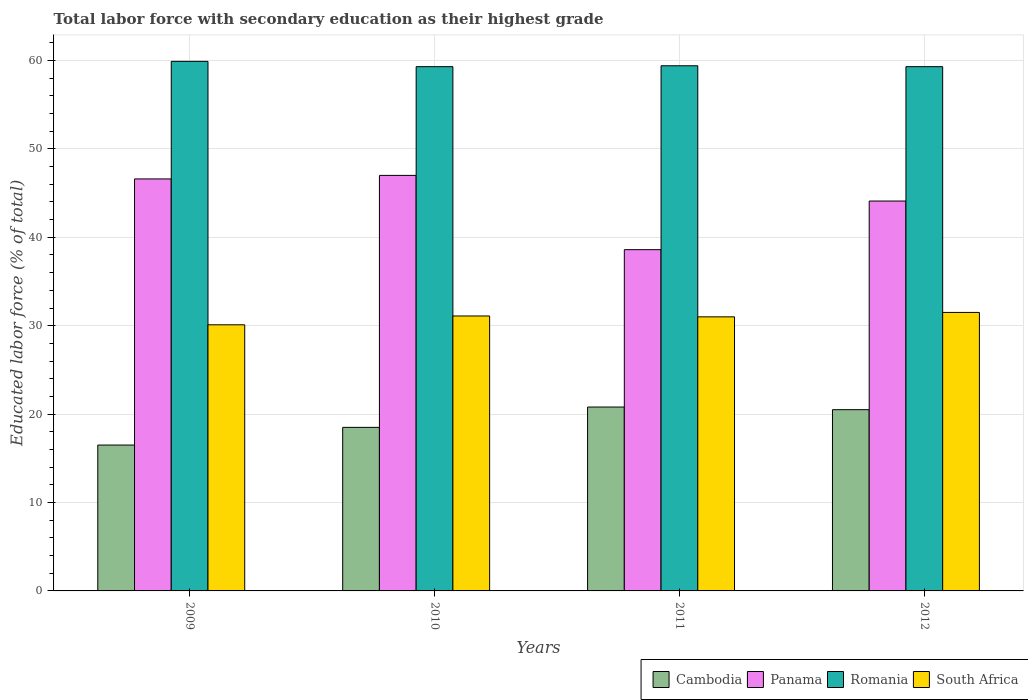Are the number of bars per tick equal to the number of legend labels?
Make the answer very short. Yes. How many bars are there on the 3rd tick from the left?
Provide a succinct answer. 4. How many bars are there on the 3rd tick from the right?
Your answer should be very brief. 4. In how many cases, is the number of bars for a given year not equal to the number of legend labels?
Provide a short and direct response. 0. What is the percentage of total labor force with primary education in Panama in 2009?
Provide a succinct answer. 46.6. Across all years, what is the maximum percentage of total labor force with primary education in Cambodia?
Your answer should be compact. 20.8. In which year was the percentage of total labor force with primary education in Romania maximum?
Make the answer very short. 2009. What is the total percentage of total labor force with primary education in South Africa in the graph?
Provide a short and direct response. 123.7. What is the difference between the percentage of total labor force with primary education in Romania in 2009 and that in 2011?
Provide a succinct answer. 0.5. What is the difference between the percentage of total labor force with primary education in Panama in 2010 and the percentage of total labor force with primary education in Cambodia in 2012?
Make the answer very short. 26.5. What is the average percentage of total labor force with primary education in Romania per year?
Make the answer very short. 59.48. In the year 2010, what is the difference between the percentage of total labor force with primary education in Cambodia and percentage of total labor force with primary education in Panama?
Your answer should be compact. -28.5. What is the ratio of the percentage of total labor force with primary education in Panama in 2011 to that in 2012?
Make the answer very short. 0.88. What is the difference between the highest and the second highest percentage of total labor force with primary education in Romania?
Your answer should be compact. 0.5. What is the difference between the highest and the lowest percentage of total labor force with primary education in Cambodia?
Make the answer very short. 4.3. In how many years, is the percentage of total labor force with primary education in Romania greater than the average percentage of total labor force with primary education in Romania taken over all years?
Your answer should be compact. 1. What does the 4th bar from the left in 2011 represents?
Ensure brevity in your answer.  South Africa. What does the 4th bar from the right in 2010 represents?
Provide a succinct answer. Cambodia. What is the difference between two consecutive major ticks on the Y-axis?
Provide a short and direct response. 10. Does the graph contain any zero values?
Your response must be concise. No. Does the graph contain grids?
Provide a short and direct response. Yes. How many legend labels are there?
Offer a terse response. 4. What is the title of the graph?
Ensure brevity in your answer.  Total labor force with secondary education as their highest grade. What is the label or title of the Y-axis?
Your answer should be compact. Educated labor force (% of total). What is the Educated labor force (% of total) in Cambodia in 2009?
Give a very brief answer. 16.5. What is the Educated labor force (% of total) of Panama in 2009?
Your response must be concise. 46.6. What is the Educated labor force (% of total) in Romania in 2009?
Offer a very short reply. 59.9. What is the Educated labor force (% of total) in South Africa in 2009?
Your answer should be very brief. 30.1. What is the Educated labor force (% of total) of Cambodia in 2010?
Provide a short and direct response. 18.5. What is the Educated labor force (% of total) of Romania in 2010?
Keep it short and to the point. 59.3. What is the Educated labor force (% of total) of South Africa in 2010?
Offer a terse response. 31.1. What is the Educated labor force (% of total) in Cambodia in 2011?
Offer a terse response. 20.8. What is the Educated labor force (% of total) in Panama in 2011?
Your answer should be very brief. 38.6. What is the Educated labor force (% of total) of Romania in 2011?
Ensure brevity in your answer.  59.4. What is the Educated labor force (% of total) of South Africa in 2011?
Give a very brief answer. 31. What is the Educated labor force (% of total) of Panama in 2012?
Offer a terse response. 44.1. What is the Educated labor force (% of total) of Romania in 2012?
Keep it short and to the point. 59.3. What is the Educated labor force (% of total) of South Africa in 2012?
Ensure brevity in your answer.  31.5. Across all years, what is the maximum Educated labor force (% of total) in Cambodia?
Your response must be concise. 20.8. Across all years, what is the maximum Educated labor force (% of total) in Romania?
Your answer should be very brief. 59.9. Across all years, what is the maximum Educated labor force (% of total) of South Africa?
Provide a short and direct response. 31.5. Across all years, what is the minimum Educated labor force (% of total) of Panama?
Provide a short and direct response. 38.6. Across all years, what is the minimum Educated labor force (% of total) of Romania?
Offer a very short reply. 59.3. Across all years, what is the minimum Educated labor force (% of total) of South Africa?
Keep it short and to the point. 30.1. What is the total Educated labor force (% of total) of Cambodia in the graph?
Give a very brief answer. 76.3. What is the total Educated labor force (% of total) in Panama in the graph?
Keep it short and to the point. 176.3. What is the total Educated labor force (% of total) in Romania in the graph?
Your answer should be compact. 237.9. What is the total Educated labor force (% of total) in South Africa in the graph?
Offer a terse response. 123.7. What is the difference between the Educated labor force (% of total) in Panama in 2009 and that in 2010?
Provide a succinct answer. -0.4. What is the difference between the Educated labor force (% of total) of Panama in 2009 and that in 2011?
Offer a terse response. 8. What is the difference between the Educated labor force (% of total) of Romania in 2009 and that in 2011?
Keep it short and to the point. 0.5. What is the difference between the Educated labor force (% of total) of South Africa in 2009 and that in 2011?
Provide a short and direct response. -0.9. What is the difference between the Educated labor force (% of total) of Panama in 2009 and that in 2012?
Your answer should be very brief. 2.5. What is the difference between the Educated labor force (% of total) in South Africa in 2009 and that in 2012?
Your answer should be very brief. -1.4. What is the difference between the Educated labor force (% of total) of Cambodia in 2010 and that in 2011?
Provide a short and direct response. -2.3. What is the difference between the Educated labor force (% of total) of Panama in 2010 and that in 2011?
Ensure brevity in your answer.  8.4. What is the difference between the Educated labor force (% of total) of Romania in 2010 and that in 2011?
Offer a very short reply. -0.1. What is the difference between the Educated labor force (% of total) in South Africa in 2010 and that in 2011?
Give a very brief answer. 0.1. What is the difference between the Educated labor force (% of total) of Cambodia in 2010 and that in 2012?
Provide a succinct answer. -2. What is the difference between the Educated labor force (% of total) in Romania in 2010 and that in 2012?
Offer a very short reply. 0. What is the difference between the Educated labor force (% of total) in Panama in 2011 and that in 2012?
Your answer should be very brief. -5.5. What is the difference between the Educated labor force (% of total) of South Africa in 2011 and that in 2012?
Your answer should be very brief. -0.5. What is the difference between the Educated labor force (% of total) in Cambodia in 2009 and the Educated labor force (% of total) in Panama in 2010?
Make the answer very short. -30.5. What is the difference between the Educated labor force (% of total) in Cambodia in 2009 and the Educated labor force (% of total) in Romania in 2010?
Keep it short and to the point. -42.8. What is the difference between the Educated labor force (% of total) of Cambodia in 2009 and the Educated labor force (% of total) of South Africa in 2010?
Your response must be concise. -14.6. What is the difference between the Educated labor force (% of total) in Panama in 2009 and the Educated labor force (% of total) in Romania in 2010?
Make the answer very short. -12.7. What is the difference between the Educated labor force (% of total) in Panama in 2009 and the Educated labor force (% of total) in South Africa in 2010?
Your answer should be compact. 15.5. What is the difference between the Educated labor force (% of total) of Romania in 2009 and the Educated labor force (% of total) of South Africa in 2010?
Your answer should be very brief. 28.8. What is the difference between the Educated labor force (% of total) in Cambodia in 2009 and the Educated labor force (% of total) in Panama in 2011?
Your response must be concise. -22.1. What is the difference between the Educated labor force (% of total) in Cambodia in 2009 and the Educated labor force (% of total) in Romania in 2011?
Your response must be concise. -42.9. What is the difference between the Educated labor force (% of total) of Cambodia in 2009 and the Educated labor force (% of total) of South Africa in 2011?
Make the answer very short. -14.5. What is the difference between the Educated labor force (% of total) of Romania in 2009 and the Educated labor force (% of total) of South Africa in 2011?
Give a very brief answer. 28.9. What is the difference between the Educated labor force (% of total) in Cambodia in 2009 and the Educated labor force (% of total) in Panama in 2012?
Provide a succinct answer. -27.6. What is the difference between the Educated labor force (% of total) in Cambodia in 2009 and the Educated labor force (% of total) in Romania in 2012?
Give a very brief answer. -42.8. What is the difference between the Educated labor force (% of total) in Panama in 2009 and the Educated labor force (% of total) in Romania in 2012?
Provide a short and direct response. -12.7. What is the difference between the Educated labor force (% of total) of Panama in 2009 and the Educated labor force (% of total) of South Africa in 2012?
Ensure brevity in your answer.  15.1. What is the difference between the Educated labor force (% of total) of Romania in 2009 and the Educated labor force (% of total) of South Africa in 2012?
Offer a very short reply. 28.4. What is the difference between the Educated labor force (% of total) in Cambodia in 2010 and the Educated labor force (% of total) in Panama in 2011?
Your answer should be very brief. -20.1. What is the difference between the Educated labor force (% of total) in Cambodia in 2010 and the Educated labor force (% of total) in Romania in 2011?
Offer a terse response. -40.9. What is the difference between the Educated labor force (% of total) in Panama in 2010 and the Educated labor force (% of total) in South Africa in 2011?
Offer a very short reply. 16. What is the difference between the Educated labor force (% of total) of Romania in 2010 and the Educated labor force (% of total) of South Africa in 2011?
Your answer should be compact. 28.3. What is the difference between the Educated labor force (% of total) of Cambodia in 2010 and the Educated labor force (% of total) of Panama in 2012?
Make the answer very short. -25.6. What is the difference between the Educated labor force (% of total) of Cambodia in 2010 and the Educated labor force (% of total) of Romania in 2012?
Your answer should be very brief. -40.8. What is the difference between the Educated labor force (% of total) of Panama in 2010 and the Educated labor force (% of total) of South Africa in 2012?
Offer a terse response. 15.5. What is the difference between the Educated labor force (% of total) of Romania in 2010 and the Educated labor force (% of total) of South Africa in 2012?
Your response must be concise. 27.8. What is the difference between the Educated labor force (% of total) in Cambodia in 2011 and the Educated labor force (% of total) in Panama in 2012?
Keep it short and to the point. -23.3. What is the difference between the Educated labor force (% of total) in Cambodia in 2011 and the Educated labor force (% of total) in Romania in 2012?
Provide a succinct answer. -38.5. What is the difference between the Educated labor force (% of total) in Panama in 2011 and the Educated labor force (% of total) in Romania in 2012?
Provide a succinct answer. -20.7. What is the difference between the Educated labor force (% of total) of Romania in 2011 and the Educated labor force (% of total) of South Africa in 2012?
Keep it short and to the point. 27.9. What is the average Educated labor force (% of total) of Cambodia per year?
Offer a terse response. 19.07. What is the average Educated labor force (% of total) in Panama per year?
Provide a succinct answer. 44.08. What is the average Educated labor force (% of total) in Romania per year?
Give a very brief answer. 59.48. What is the average Educated labor force (% of total) of South Africa per year?
Offer a terse response. 30.93. In the year 2009, what is the difference between the Educated labor force (% of total) in Cambodia and Educated labor force (% of total) in Panama?
Provide a short and direct response. -30.1. In the year 2009, what is the difference between the Educated labor force (% of total) in Cambodia and Educated labor force (% of total) in Romania?
Make the answer very short. -43.4. In the year 2009, what is the difference between the Educated labor force (% of total) in Cambodia and Educated labor force (% of total) in South Africa?
Make the answer very short. -13.6. In the year 2009, what is the difference between the Educated labor force (% of total) of Panama and Educated labor force (% of total) of Romania?
Offer a very short reply. -13.3. In the year 2009, what is the difference between the Educated labor force (% of total) in Panama and Educated labor force (% of total) in South Africa?
Provide a short and direct response. 16.5. In the year 2009, what is the difference between the Educated labor force (% of total) of Romania and Educated labor force (% of total) of South Africa?
Ensure brevity in your answer.  29.8. In the year 2010, what is the difference between the Educated labor force (% of total) in Cambodia and Educated labor force (% of total) in Panama?
Your answer should be very brief. -28.5. In the year 2010, what is the difference between the Educated labor force (% of total) of Cambodia and Educated labor force (% of total) of Romania?
Provide a short and direct response. -40.8. In the year 2010, what is the difference between the Educated labor force (% of total) in Panama and Educated labor force (% of total) in Romania?
Ensure brevity in your answer.  -12.3. In the year 2010, what is the difference between the Educated labor force (% of total) of Panama and Educated labor force (% of total) of South Africa?
Make the answer very short. 15.9. In the year 2010, what is the difference between the Educated labor force (% of total) in Romania and Educated labor force (% of total) in South Africa?
Give a very brief answer. 28.2. In the year 2011, what is the difference between the Educated labor force (% of total) of Cambodia and Educated labor force (% of total) of Panama?
Make the answer very short. -17.8. In the year 2011, what is the difference between the Educated labor force (% of total) of Cambodia and Educated labor force (% of total) of Romania?
Your response must be concise. -38.6. In the year 2011, what is the difference between the Educated labor force (% of total) in Panama and Educated labor force (% of total) in Romania?
Your answer should be very brief. -20.8. In the year 2011, what is the difference between the Educated labor force (% of total) in Romania and Educated labor force (% of total) in South Africa?
Provide a succinct answer. 28.4. In the year 2012, what is the difference between the Educated labor force (% of total) in Cambodia and Educated labor force (% of total) in Panama?
Give a very brief answer. -23.6. In the year 2012, what is the difference between the Educated labor force (% of total) in Cambodia and Educated labor force (% of total) in Romania?
Your response must be concise. -38.8. In the year 2012, what is the difference between the Educated labor force (% of total) of Cambodia and Educated labor force (% of total) of South Africa?
Your response must be concise. -11. In the year 2012, what is the difference between the Educated labor force (% of total) of Panama and Educated labor force (% of total) of Romania?
Your answer should be very brief. -15.2. In the year 2012, what is the difference between the Educated labor force (% of total) in Panama and Educated labor force (% of total) in South Africa?
Offer a terse response. 12.6. In the year 2012, what is the difference between the Educated labor force (% of total) in Romania and Educated labor force (% of total) in South Africa?
Your answer should be compact. 27.8. What is the ratio of the Educated labor force (% of total) of Cambodia in 2009 to that in 2010?
Offer a terse response. 0.89. What is the ratio of the Educated labor force (% of total) of Romania in 2009 to that in 2010?
Provide a succinct answer. 1.01. What is the ratio of the Educated labor force (% of total) of South Africa in 2009 to that in 2010?
Your response must be concise. 0.97. What is the ratio of the Educated labor force (% of total) in Cambodia in 2009 to that in 2011?
Give a very brief answer. 0.79. What is the ratio of the Educated labor force (% of total) in Panama in 2009 to that in 2011?
Offer a terse response. 1.21. What is the ratio of the Educated labor force (% of total) of Romania in 2009 to that in 2011?
Offer a very short reply. 1.01. What is the ratio of the Educated labor force (% of total) in Cambodia in 2009 to that in 2012?
Your response must be concise. 0.8. What is the ratio of the Educated labor force (% of total) of Panama in 2009 to that in 2012?
Your answer should be very brief. 1.06. What is the ratio of the Educated labor force (% of total) of Romania in 2009 to that in 2012?
Keep it short and to the point. 1.01. What is the ratio of the Educated labor force (% of total) in South Africa in 2009 to that in 2012?
Ensure brevity in your answer.  0.96. What is the ratio of the Educated labor force (% of total) of Cambodia in 2010 to that in 2011?
Provide a succinct answer. 0.89. What is the ratio of the Educated labor force (% of total) of Panama in 2010 to that in 2011?
Your answer should be compact. 1.22. What is the ratio of the Educated labor force (% of total) in Cambodia in 2010 to that in 2012?
Provide a succinct answer. 0.9. What is the ratio of the Educated labor force (% of total) in Panama in 2010 to that in 2012?
Offer a very short reply. 1.07. What is the ratio of the Educated labor force (% of total) of Romania in 2010 to that in 2012?
Provide a succinct answer. 1. What is the ratio of the Educated labor force (% of total) in South Africa in 2010 to that in 2012?
Make the answer very short. 0.99. What is the ratio of the Educated labor force (% of total) in Cambodia in 2011 to that in 2012?
Make the answer very short. 1.01. What is the ratio of the Educated labor force (% of total) in Panama in 2011 to that in 2012?
Your response must be concise. 0.88. What is the ratio of the Educated labor force (% of total) of Romania in 2011 to that in 2012?
Keep it short and to the point. 1. What is the ratio of the Educated labor force (% of total) of South Africa in 2011 to that in 2012?
Give a very brief answer. 0.98. What is the difference between the highest and the second highest Educated labor force (% of total) of Cambodia?
Your answer should be compact. 0.3. What is the difference between the highest and the second highest Educated labor force (% of total) in Panama?
Keep it short and to the point. 0.4. What is the difference between the highest and the second highest Educated labor force (% of total) in South Africa?
Provide a short and direct response. 0.4. What is the difference between the highest and the lowest Educated labor force (% of total) in Panama?
Provide a succinct answer. 8.4. What is the difference between the highest and the lowest Educated labor force (% of total) of Romania?
Your response must be concise. 0.6. 